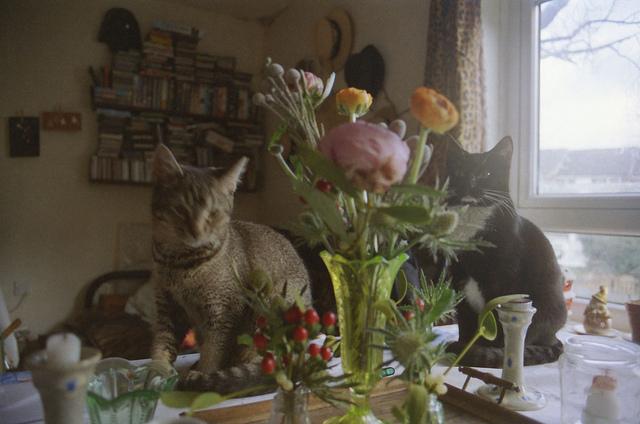What animals are on display?
Quick response, please. Cats. Are these flowers dangerous to cats?
Write a very short answer. No. Is this an oriental vase?
Keep it brief. No. Are all cats of the same breed?
Quick response, please. No. Are these flowers real or fake?
Quick response, please. Real. Is this a store window?
Be succinct. No. What is beside the cat?
Short answer required. Flowers. Are these animals alive?
Keep it brief. Yes. Are all the flowers in jars?
Quick response, please. Yes. Is there a serenity about this picture?
Be succinct. Yes. How many cats are there?
Short answer required. 2. Is this someone's home or a museum?
Concise answer only. Home. Are there kitties?
Short answer required. Yes. Do the animals have spots?
Quick response, please. No. What is the cat after?
Answer briefly. Flowers. Is this photoshopped?
Answer briefly. No. What breed of cat?
Write a very short answer. Tabby. Where is the Tabby cat?
Concise answer only. On left. Is the image in black and white?
Answer briefly. No. What color flowers are on the top right?
Short answer required. Orange. How many paws can be seen on the cat?
Quick response, please. 2. What is on the wall?
Answer briefly. Cds. Do any of the animals have horns?
Concise answer only. No. What type of bottle is near the cat?
Give a very brief answer. Vase. How many animals are on the counter?
Concise answer only. 2. Is there a mirror on the right?
Short answer required. No. What kind of flowers are in the picture?
Short answer required. Roses. Is  this a color picture?
Give a very brief answer. Yes. Are the cats in bed?
Concise answer only. No. 